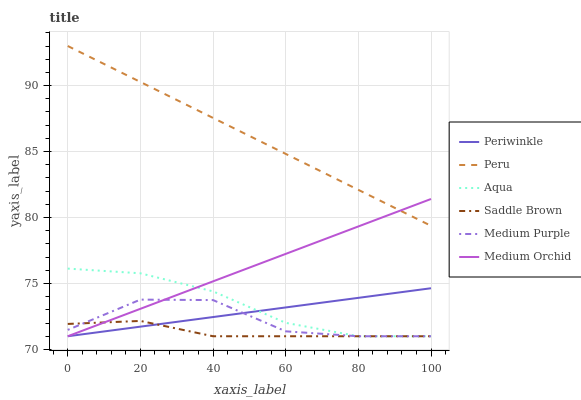Does Saddle Brown have the minimum area under the curve?
Answer yes or no. Yes. Does Peru have the maximum area under the curve?
Answer yes or no. Yes. Does Aqua have the minimum area under the curve?
Answer yes or no. No. Does Aqua have the maximum area under the curve?
Answer yes or no. No. Is Periwinkle the smoothest?
Answer yes or no. Yes. Is Medium Purple the roughest?
Answer yes or no. Yes. Is Aqua the smoothest?
Answer yes or no. No. Is Aqua the roughest?
Answer yes or no. No. Does Peru have the lowest value?
Answer yes or no. No. Does Peru have the highest value?
Answer yes or no. Yes. Does Aqua have the highest value?
Answer yes or no. No. Is Medium Purple less than Peru?
Answer yes or no. Yes. Is Peru greater than Periwinkle?
Answer yes or no. Yes. Does Medium Orchid intersect Periwinkle?
Answer yes or no. Yes. Is Medium Orchid less than Periwinkle?
Answer yes or no. No. Is Medium Orchid greater than Periwinkle?
Answer yes or no. No. Does Medium Purple intersect Peru?
Answer yes or no. No. 